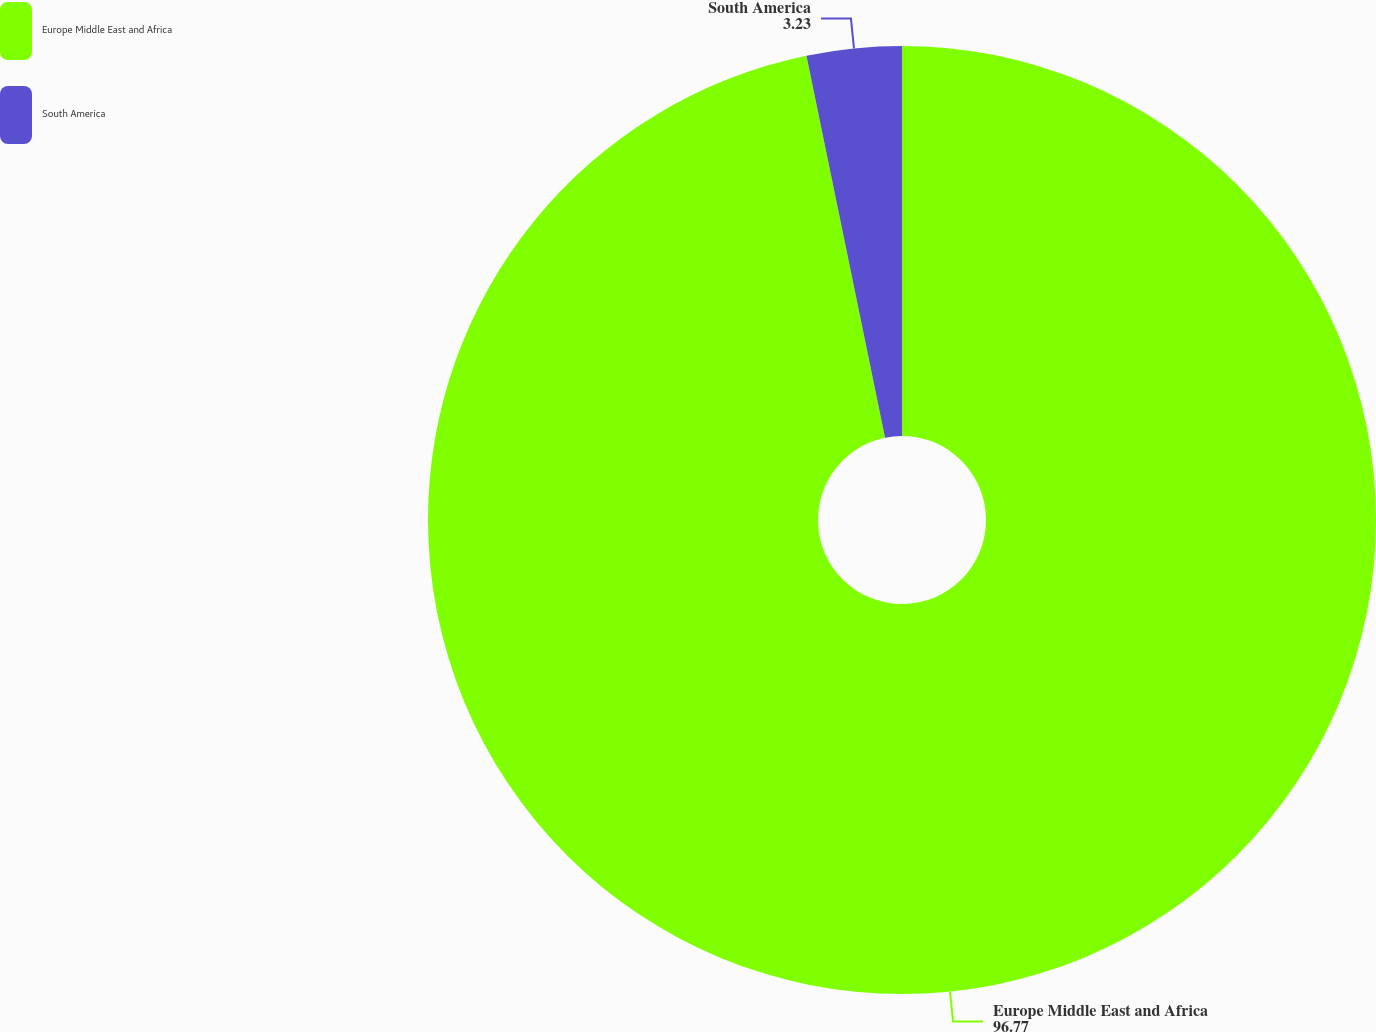<chart> <loc_0><loc_0><loc_500><loc_500><pie_chart><fcel>Europe Middle East and Africa<fcel>South America<nl><fcel>96.77%<fcel>3.23%<nl></chart> 